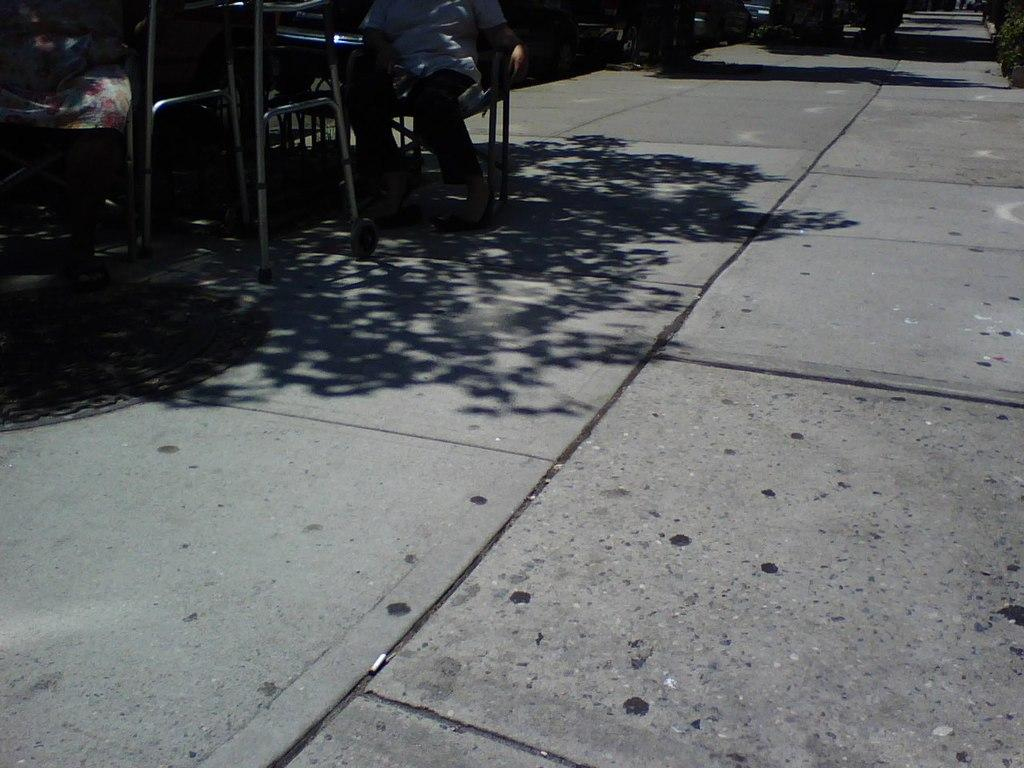Who or what can be seen in the image? There are people in the image. What are the people doing in the image? The people are seated on chairs. What type of material can be seen in the image? There are metal rods visible in the image. What type of jellyfish can be seen swimming in the image? There are no jellyfish present in the image; it features people seated on chairs with metal rods visible. 